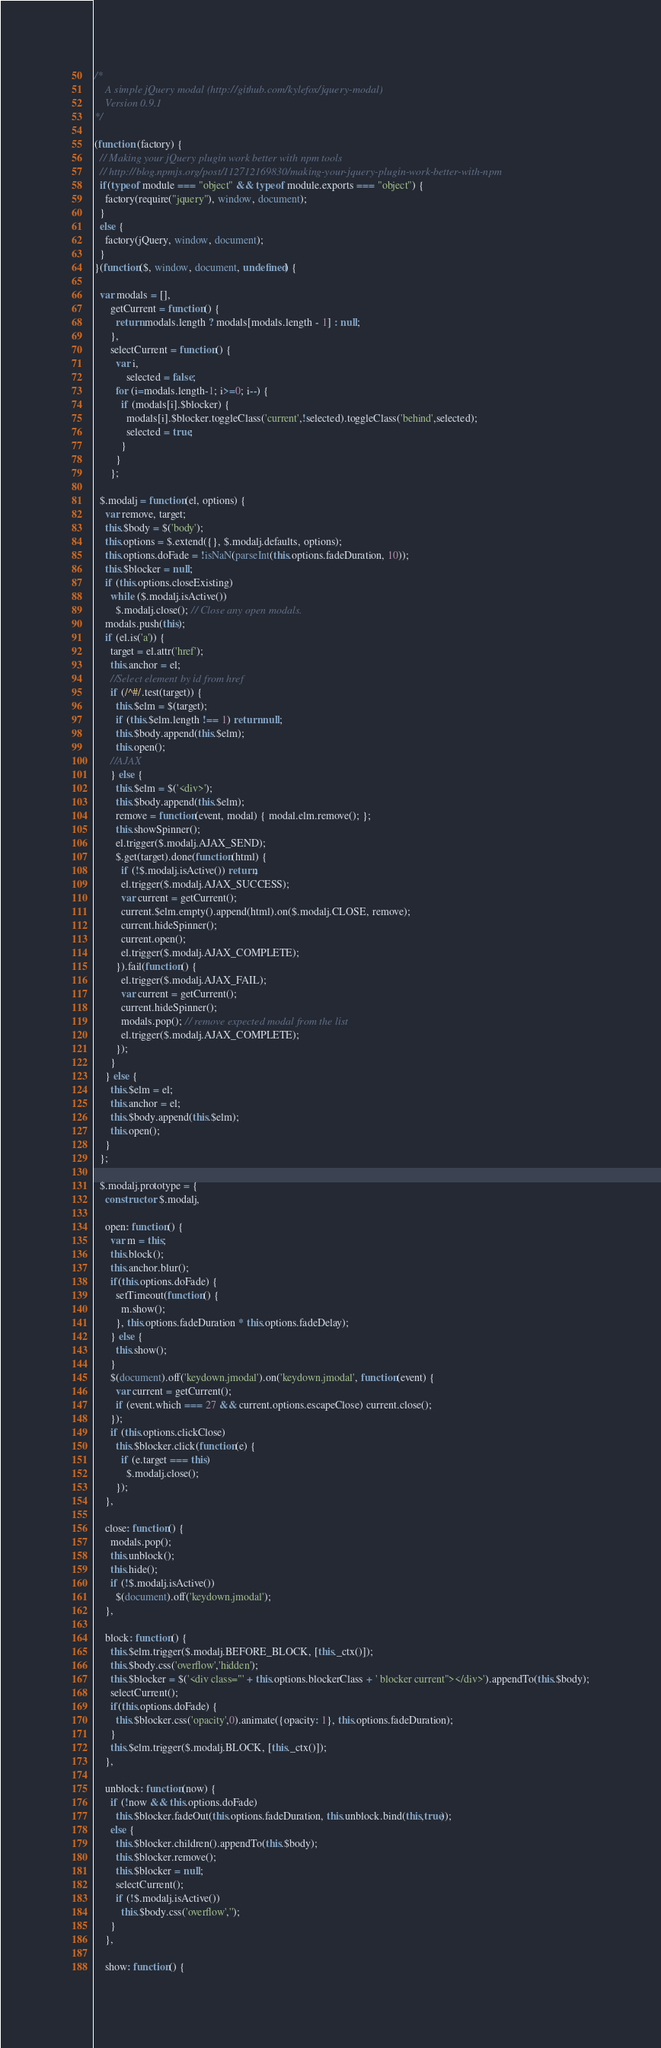<code> <loc_0><loc_0><loc_500><loc_500><_JavaScript_>/*
    A simple jQuery modal (http://github.com/kylefox/jquery-modal)
    Version 0.9.1
*/

(function (factory) {
  // Making your jQuery plugin work better with npm tools
  // http://blog.npmjs.org/post/112712169830/making-your-jquery-plugin-work-better-with-npm
  if(typeof module === "object" && typeof module.exports === "object") {
    factory(require("jquery"), window, document);
  }
  else {
    factory(jQuery, window, document);
  }
}(function($, window, document, undefined) {

  var modals = [],
      getCurrent = function() {
        return modals.length ? modals[modals.length - 1] : null;
      },
      selectCurrent = function() {
        var i,
            selected = false;
        for (i=modals.length-1; i>=0; i--) {
          if (modals[i].$blocker) {
            modals[i].$blocker.toggleClass('current',!selected).toggleClass('behind',selected);
            selected = true;
          }
        }
      };

  $.modalj = function(el, options) {
    var remove, target;
    this.$body = $('body');
    this.options = $.extend({}, $.modalj.defaults, options);
    this.options.doFade = !isNaN(parseInt(this.options.fadeDuration, 10));
    this.$blocker = null;
    if (this.options.closeExisting)
      while ($.modalj.isActive())
        $.modalj.close(); // Close any open modals.
    modals.push(this);
    if (el.is('a')) {
      target = el.attr('href');
      this.anchor = el;
      //Select element by id from href
      if (/^#/.test(target)) {
        this.$elm = $(target);
        if (this.$elm.length !== 1) return null;
        this.$body.append(this.$elm);
        this.open();
      //AJAX
      } else {
        this.$elm = $('<div>');
        this.$body.append(this.$elm);
        remove = function(event, modal) { modal.elm.remove(); };
        this.showSpinner();
        el.trigger($.modalj.AJAX_SEND);
        $.get(target).done(function(html) {
          if (!$.modalj.isActive()) return;
          el.trigger($.modalj.AJAX_SUCCESS);
          var current = getCurrent();
          current.$elm.empty().append(html).on($.modalj.CLOSE, remove);
          current.hideSpinner();
          current.open();
          el.trigger($.modalj.AJAX_COMPLETE);
        }).fail(function() {
          el.trigger($.modalj.AJAX_FAIL);
          var current = getCurrent();
          current.hideSpinner();
          modals.pop(); // remove expected modal from the list
          el.trigger($.modalj.AJAX_COMPLETE);
        });
      }
    } else {
      this.$elm = el;
      this.anchor = el;
      this.$body.append(this.$elm);
      this.open();
    }
  };

  $.modalj.prototype = {
    constructor: $.modalj,

    open: function() {
      var m = this;
      this.block();
      this.anchor.blur();
      if(this.options.doFade) {
        setTimeout(function() {
          m.show();
        }, this.options.fadeDuration * this.options.fadeDelay);
      } else {
        this.show();
      }
      $(document).off('keydown.jmodal').on('keydown.jmodal', function(event) {
        var current = getCurrent();
        if (event.which === 27 && current.options.escapeClose) current.close();
      });
      if (this.options.clickClose)
        this.$blocker.click(function(e) {
          if (e.target === this)
            $.modalj.close();
        });
    },

    close: function() {
      modals.pop();
      this.unblock();
      this.hide();
      if (!$.modalj.isActive())
        $(document).off('keydown.jmodal');
    },

    block: function() {
      this.$elm.trigger($.modalj.BEFORE_BLOCK, [this._ctx()]);
      this.$body.css('overflow','hidden');
      this.$blocker = $('<div class="' + this.options.blockerClass + ' blocker current"></div>').appendTo(this.$body);
      selectCurrent();
      if(this.options.doFade) {
        this.$blocker.css('opacity',0).animate({opacity: 1}, this.options.fadeDuration);
      }
      this.$elm.trigger($.modalj.BLOCK, [this._ctx()]);
    },

    unblock: function(now) {
      if (!now && this.options.doFade)
        this.$blocker.fadeOut(this.options.fadeDuration, this.unblock.bind(this,true));
      else {
        this.$blocker.children().appendTo(this.$body);
        this.$blocker.remove();
        this.$blocker = null;
        selectCurrent();
        if (!$.modalj.isActive())
          this.$body.css('overflow','');
      }
    },

    show: function() {</code> 